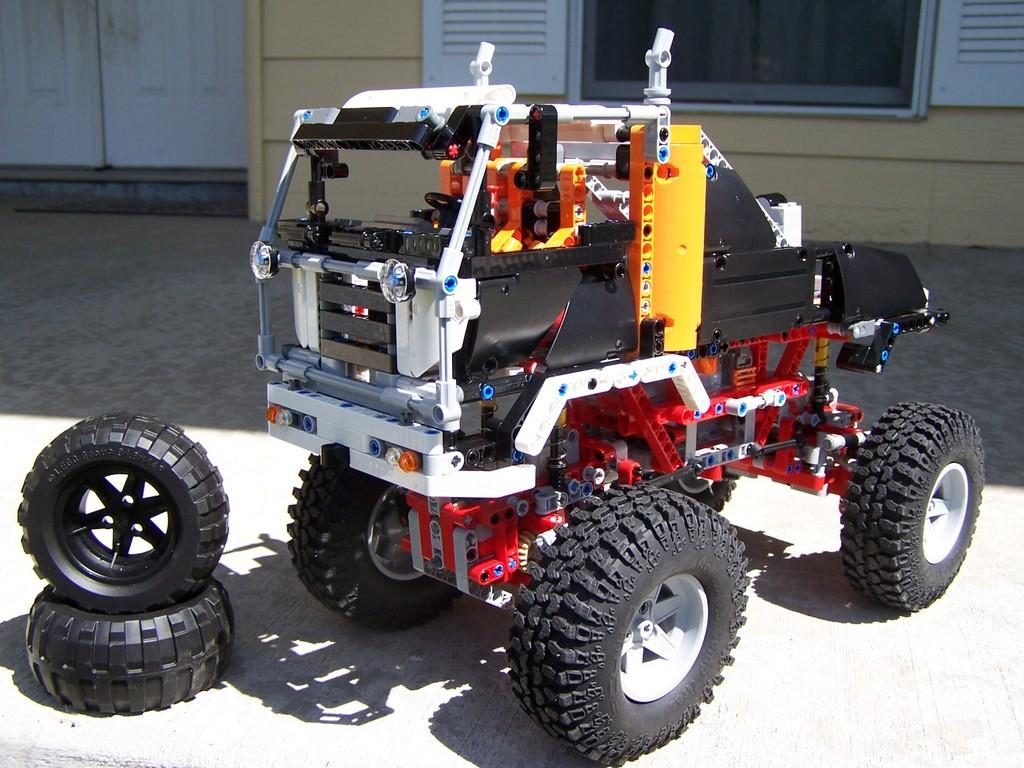What type of vehicle is in the image? There is a vehicle in the image, but the specific type is not mentioned. What can be seen behind the vehicle? There are tires behind the vehicle. What is in front of the vehicle? There are glass windows and a wooden door on the wall in front of the vehicle. What is the government's reaction to the vehicle in the image? The government's reaction is not mentioned in the image, as it does not contain any information about the government or its response to the vehicle. 